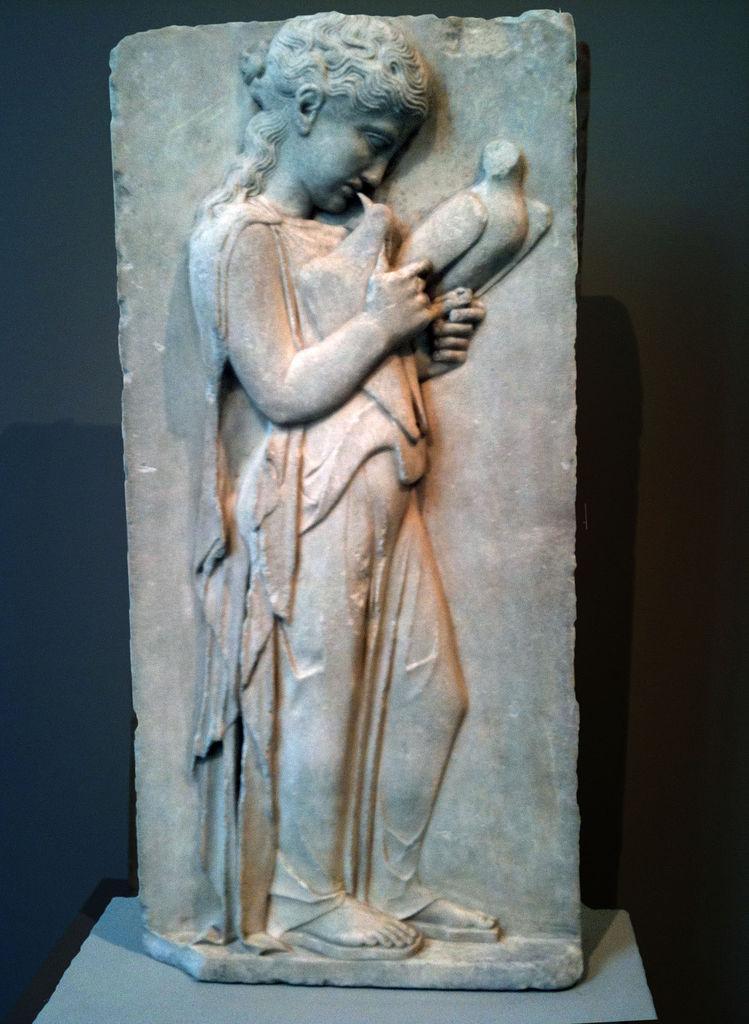Describe this image in one or two sentences. In this image I see a sculpture which is made of stone and I see that it is dark in the background and I see the sculpture on the grey color surface. 